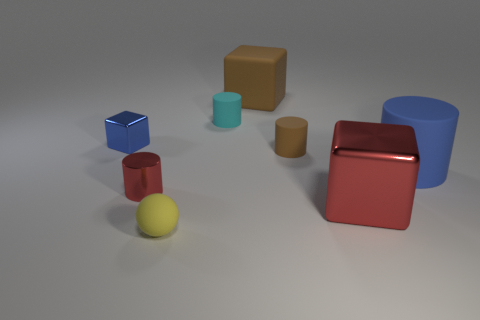Add 1 red metallic cylinders. How many objects exist? 9 Subtract all blocks. How many objects are left? 5 Add 7 yellow rubber balls. How many yellow rubber balls are left? 8 Add 3 small brown matte cylinders. How many small brown matte cylinders exist? 4 Subtract 0 gray spheres. How many objects are left? 8 Subtract all red shiny cylinders. Subtract all blue cubes. How many objects are left? 6 